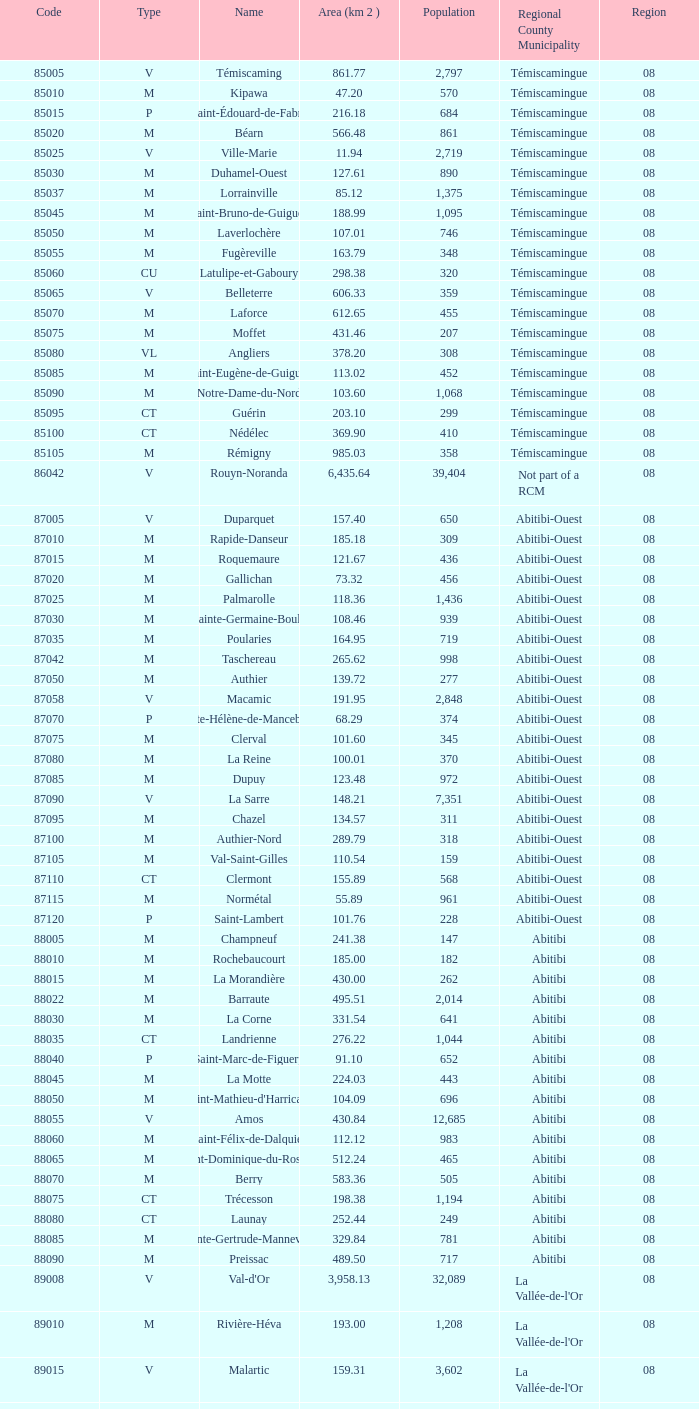What type has a population of 370? M. 